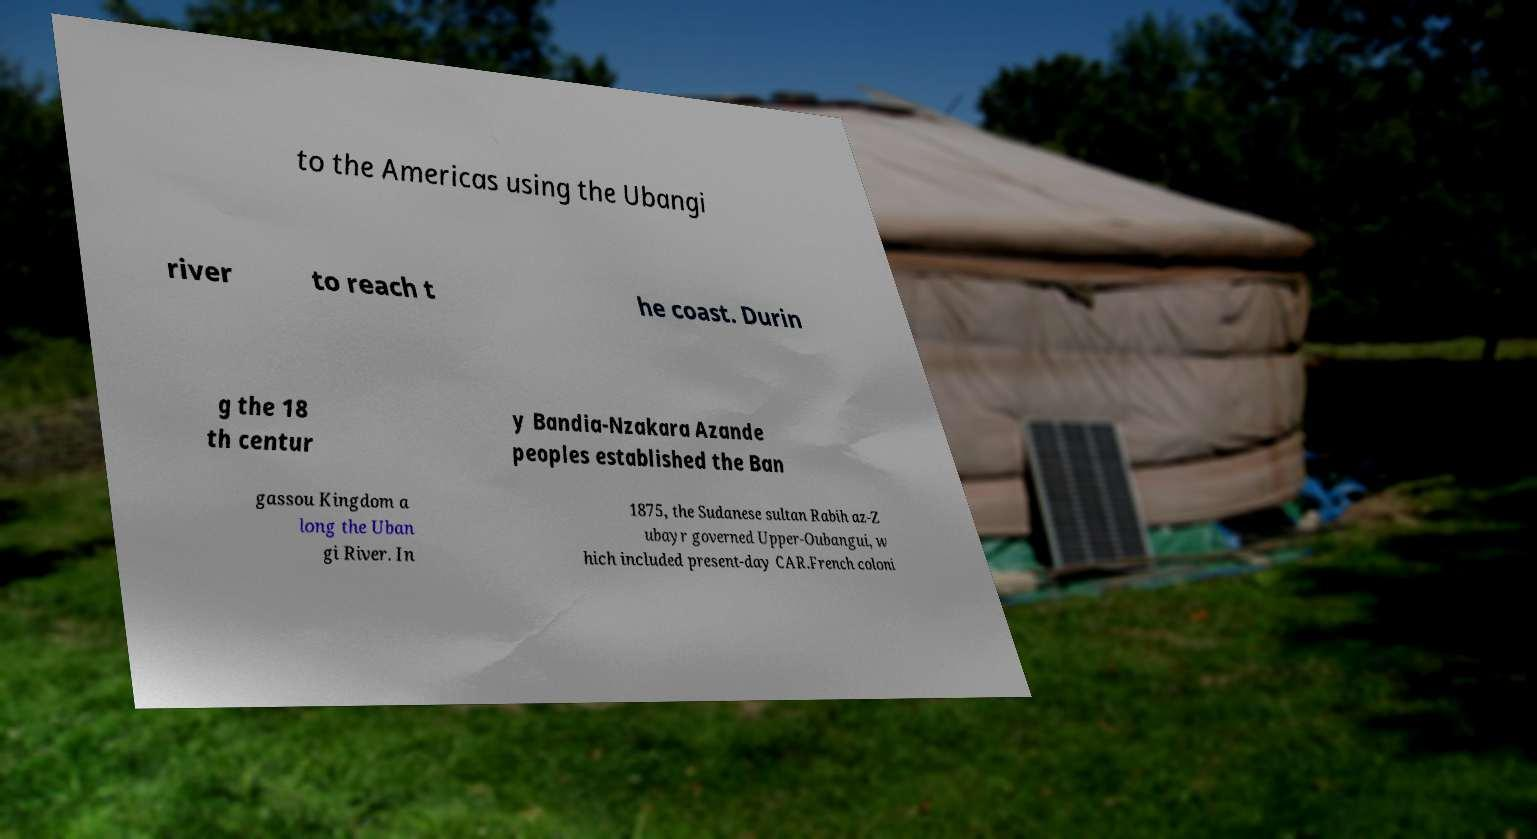Can you read and provide the text displayed in the image?This photo seems to have some interesting text. Can you extract and type it out for me? to the Americas using the Ubangi river to reach t he coast. Durin g the 18 th centur y Bandia-Nzakara Azande peoples established the Ban gassou Kingdom a long the Uban gi River. In 1875, the Sudanese sultan Rabih az-Z ubayr governed Upper-Oubangui, w hich included present-day CAR.French coloni 